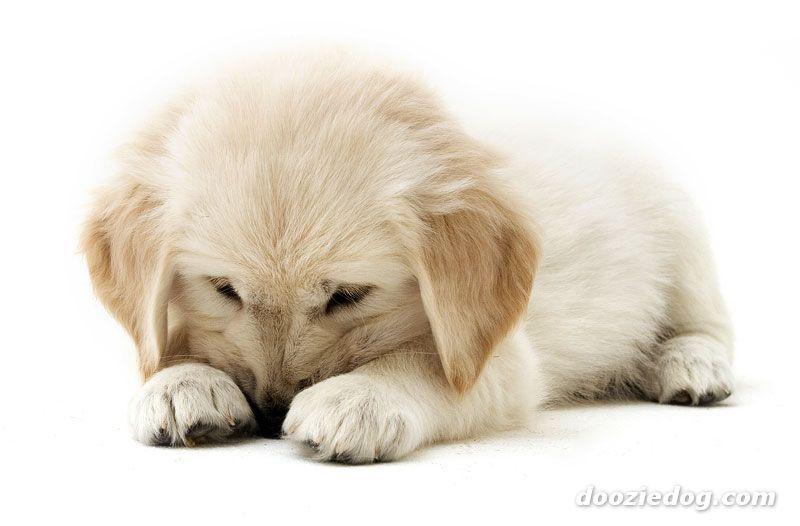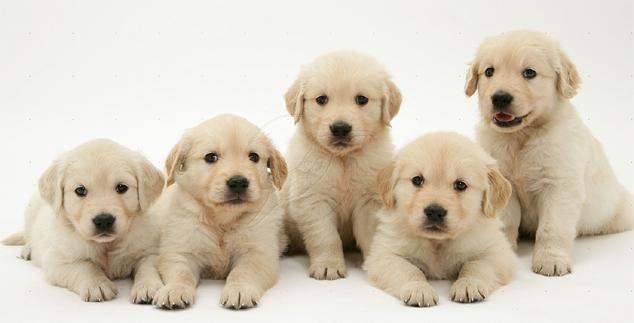The first image is the image on the left, the second image is the image on the right. Given the left and right images, does the statement "One image shows a group of five sitting and reclining puppies in an indoor setting." hold true? Answer yes or no. Yes. The first image is the image on the left, the second image is the image on the right. For the images shown, is this caption "Exactly seven dogs are shown, in groups of two and five." true? Answer yes or no. No. 